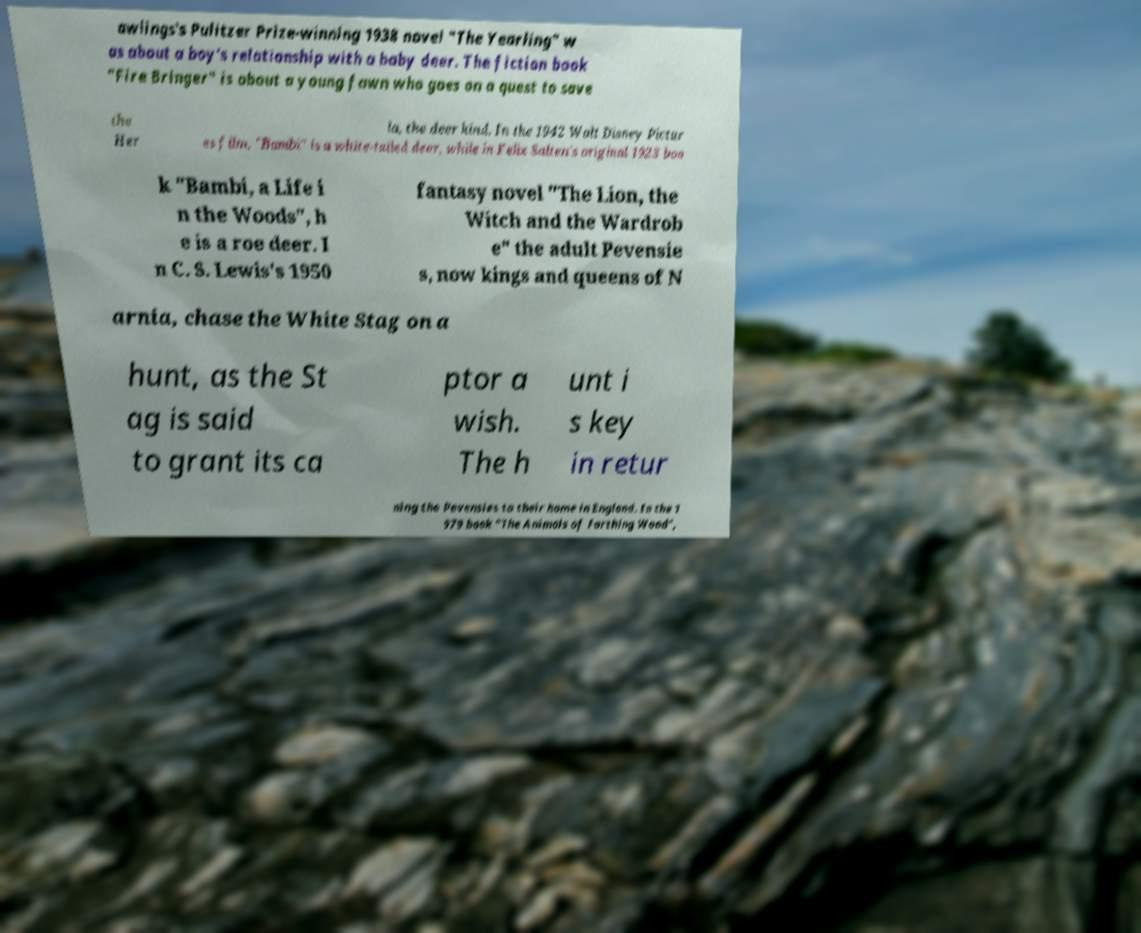Can you read and provide the text displayed in the image?This photo seems to have some interesting text. Can you extract and type it out for me? awlings's Pulitzer Prize-winning 1938 novel "The Yearling" w as about a boy's relationship with a baby deer. The fiction book "Fire Bringer" is about a young fawn who goes on a quest to save the Her la, the deer kind. In the 1942 Walt Disney Pictur es film, "Bambi" is a white-tailed deer, while in Felix Salten's original 1923 boo k "Bambi, a Life i n the Woods", h e is a roe deer. I n C. S. Lewis's 1950 fantasy novel "The Lion, the Witch and the Wardrob e" the adult Pevensie s, now kings and queens of N arnia, chase the White Stag on a hunt, as the St ag is said to grant its ca ptor a wish. The h unt i s key in retur ning the Pevensies to their home in England. In the 1 979 book "The Animals of Farthing Wood", 